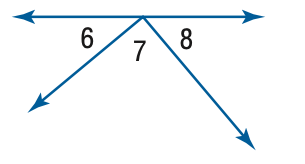Answer the mathemtical geometry problem and directly provide the correct option letter.
Question: \angle 6 and \angle 8 are complementary, m \angle 8 = 47. Find the measure of \angle 6.
Choices: A: 43 B: 47 C: 86 D: 90 A 